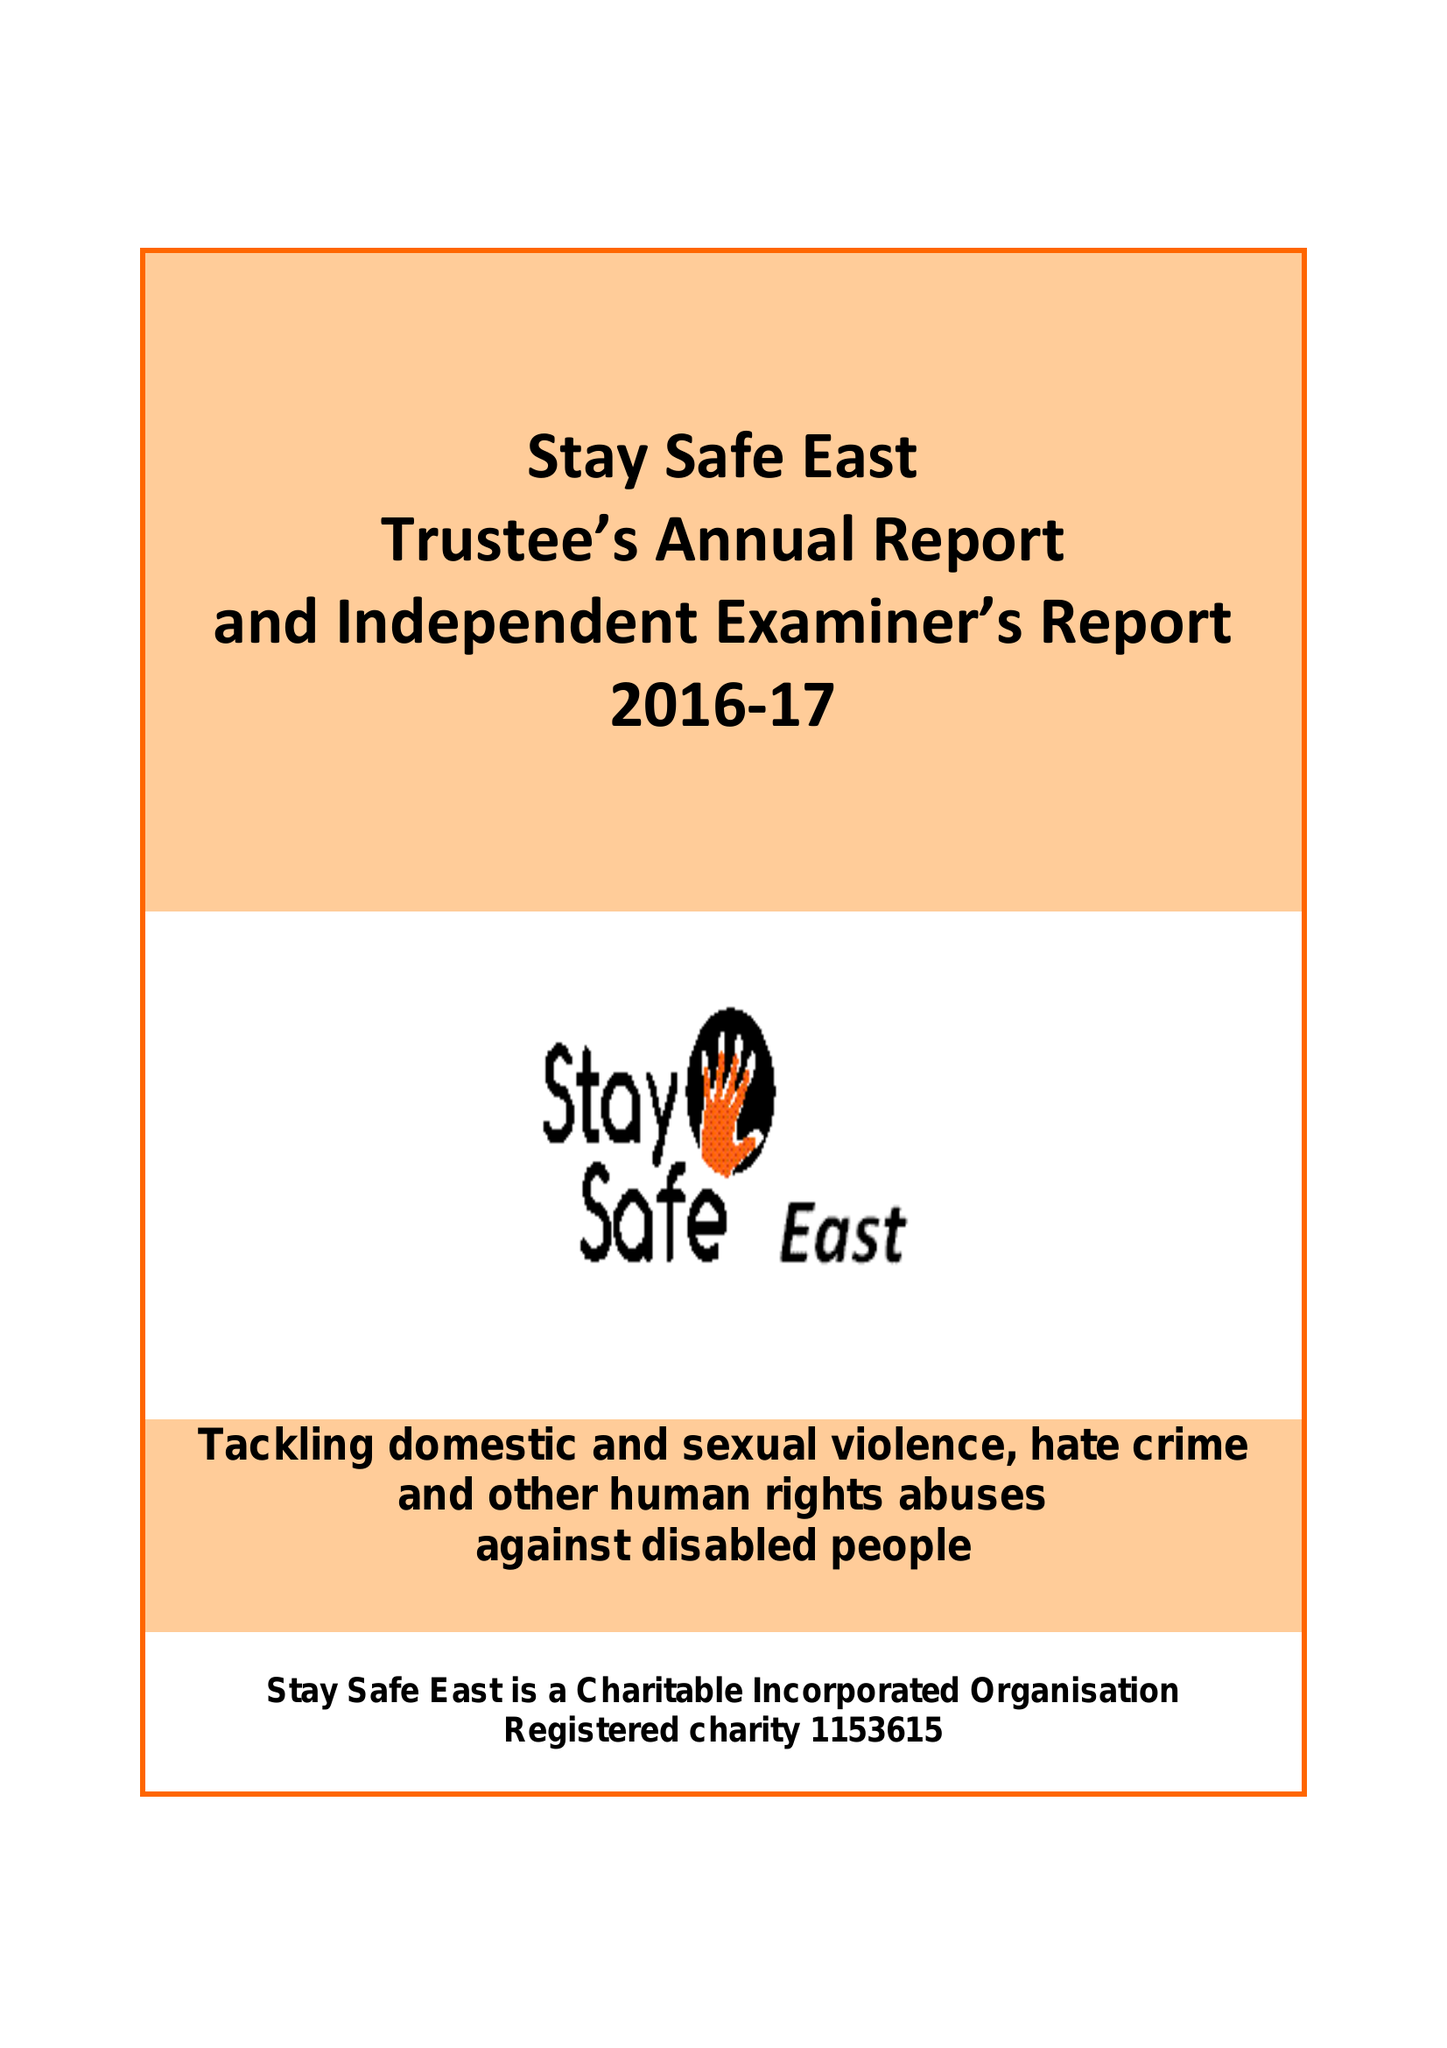What is the value for the income_annually_in_british_pounds?
Answer the question using a single word or phrase. 113245.00 